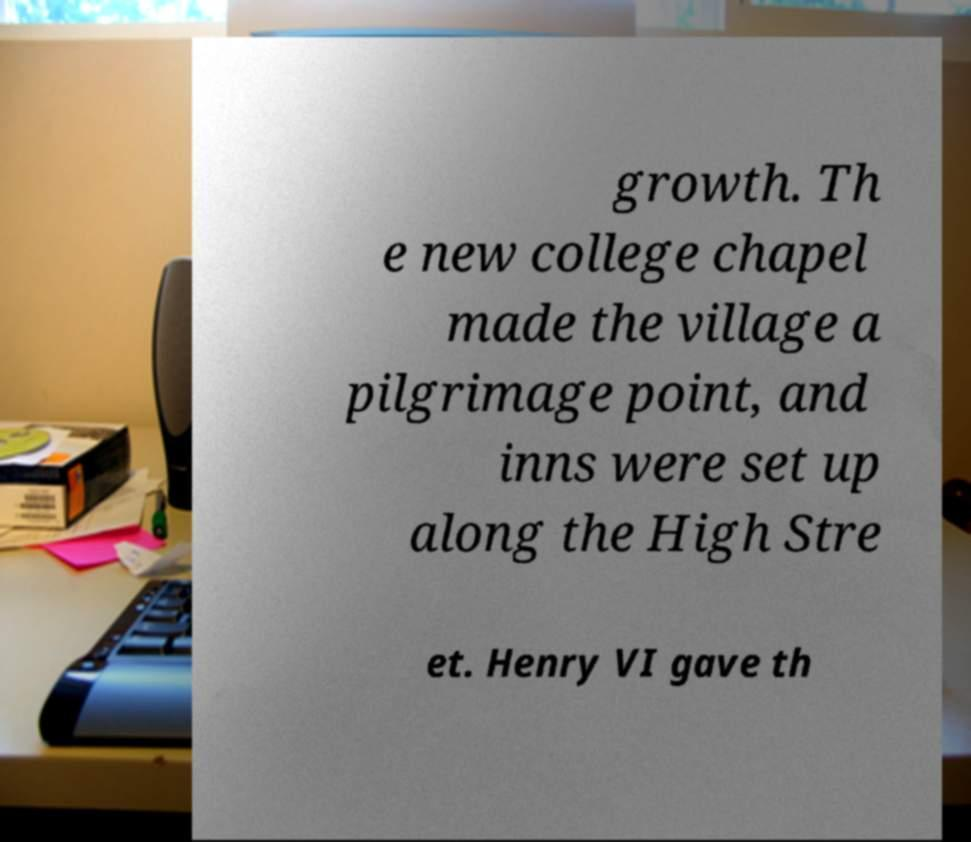Could you extract and type out the text from this image? growth. Th e new college chapel made the village a pilgrimage point, and inns were set up along the High Stre et. Henry VI gave th 